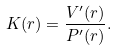<formula> <loc_0><loc_0><loc_500><loc_500>K ( r ) = \frac { V ^ { \prime } ( r ) } { P ^ { \prime } ( r ) } .</formula> 